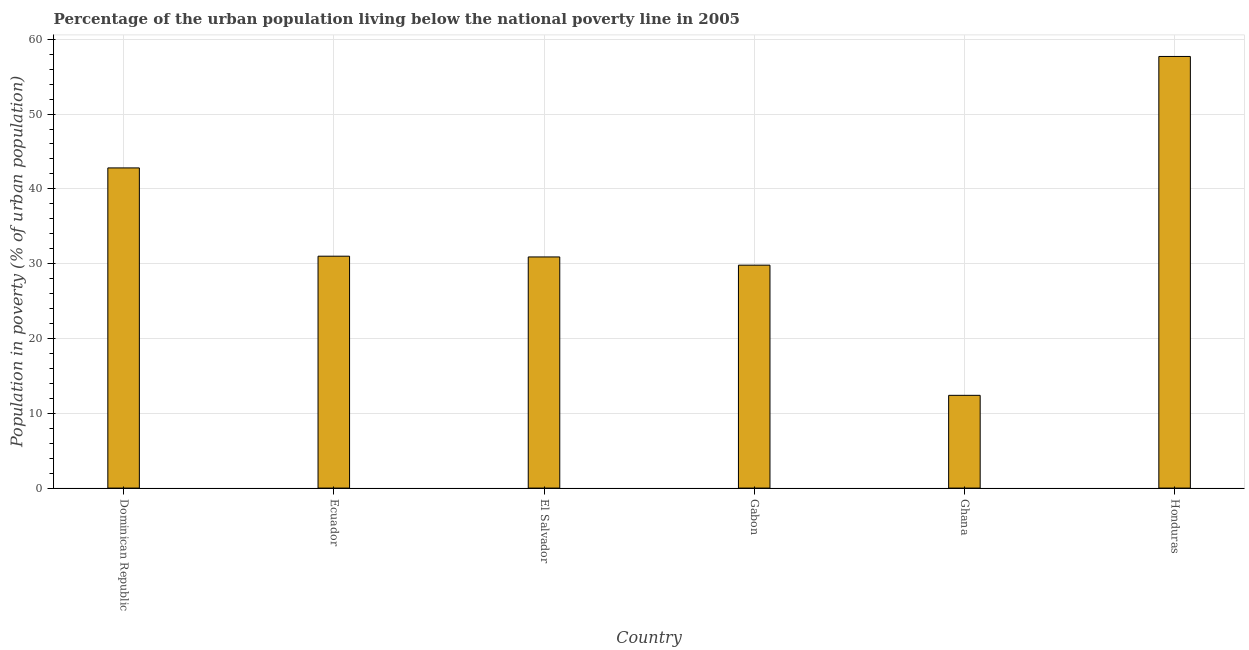What is the title of the graph?
Offer a terse response. Percentage of the urban population living below the national poverty line in 2005. What is the label or title of the X-axis?
Ensure brevity in your answer.  Country. What is the label or title of the Y-axis?
Ensure brevity in your answer.  Population in poverty (% of urban population). What is the percentage of urban population living below poverty line in Honduras?
Offer a terse response. 57.7. Across all countries, what is the maximum percentage of urban population living below poverty line?
Give a very brief answer. 57.7. Across all countries, what is the minimum percentage of urban population living below poverty line?
Keep it short and to the point. 12.4. In which country was the percentage of urban population living below poverty line maximum?
Provide a succinct answer. Honduras. In which country was the percentage of urban population living below poverty line minimum?
Make the answer very short. Ghana. What is the sum of the percentage of urban population living below poverty line?
Make the answer very short. 204.6. What is the difference between the percentage of urban population living below poverty line in Dominican Republic and Honduras?
Your answer should be very brief. -14.9. What is the average percentage of urban population living below poverty line per country?
Offer a very short reply. 34.1. What is the median percentage of urban population living below poverty line?
Offer a terse response. 30.95. What is the ratio of the percentage of urban population living below poverty line in Dominican Republic to that in Gabon?
Keep it short and to the point. 1.44. Is the difference between the percentage of urban population living below poverty line in Dominican Republic and El Salvador greater than the difference between any two countries?
Your response must be concise. No. What is the difference between the highest and the second highest percentage of urban population living below poverty line?
Give a very brief answer. 14.9. Is the sum of the percentage of urban population living below poverty line in El Salvador and Ghana greater than the maximum percentage of urban population living below poverty line across all countries?
Provide a short and direct response. No. What is the difference between the highest and the lowest percentage of urban population living below poverty line?
Offer a terse response. 45.3. In how many countries, is the percentage of urban population living below poverty line greater than the average percentage of urban population living below poverty line taken over all countries?
Ensure brevity in your answer.  2. How many bars are there?
Make the answer very short. 6. Are all the bars in the graph horizontal?
Give a very brief answer. No. How many countries are there in the graph?
Make the answer very short. 6. Are the values on the major ticks of Y-axis written in scientific E-notation?
Your answer should be compact. No. What is the Population in poverty (% of urban population) of Dominican Republic?
Provide a short and direct response. 42.8. What is the Population in poverty (% of urban population) of Ecuador?
Offer a terse response. 31. What is the Population in poverty (% of urban population) in El Salvador?
Make the answer very short. 30.9. What is the Population in poverty (% of urban population) in Gabon?
Offer a terse response. 29.8. What is the Population in poverty (% of urban population) in Ghana?
Provide a succinct answer. 12.4. What is the Population in poverty (% of urban population) of Honduras?
Your response must be concise. 57.7. What is the difference between the Population in poverty (% of urban population) in Dominican Republic and Ecuador?
Your answer should be very brief. 11.8. What is the difference between the Population in poverty (% of urban population) in Dominican Republic and Gabon?
Provide a short and direct response. 13. What is the difference between the Population in poverty (% of urban population) in Dominican Republic and Ghana?
Provide a succinct answer. 30.4. What is the difference between the Population in poverty (% of urban population) in Dominican Republic and Honduras?
Your response must be concise. -14.9. What is the difference between the Population in poverty (% of urban population) in Ecuador and Honduras?
Provide a short and direct response. -26.7. What is the difference between the Population in poverty (% of urban population) in El Salvador and Gabon?
Offer a very short reply. 1.1. What is the difference between the Population in poverty (% of urban population) in El Salvador and Ghana?
Provide a succinct answer. 18.5. What is the difference between the Population in poverty (% of urban population) in El Salvador and Honduras?
Make the answer very short. -26.8. What is the difference between the Population in poverty (% of urban population) in Gabon and Ghana?
Ensure brevity in your answer.  17.4. What is the difference between the Population in poverty (% of urban population) in Gabon and Honduras?
Your answer should be compact. -27.9. What is the difference between the Population in poverty (% of urban population) in Ghana and Honduras?
Your answer should be very brief. -45.3. What is the ratio of the Population in poverty (% of urban population) in Dominican Republic to that in Ecuador?
Your answer should be compact. 1.38. What is the ratio of the Population in poverty (% of urban population) in Dominican Republic to that in El Salvador?
Your answer should be compact. 1.39. What is the ratio of the Population in poverty (% of urban population) in Dominican Republic to that in Gabon?
Make the answer very short. 1.44. What is the ratio of the Population in poverty (% of urban population) in Dominican Republic to that in Ghana?
Your answer should be compact. 3.45. What is the ratio of the Population in poverty (% of urban population) in Dominican Republic to that in Honduras?
Make the answer very short. 0.74. What is the ratio of the Population in poverty (% of urban population) in Ecuador to that in Gabon?
Provide a succinct answer. 1.04. What is the ratio of the Population in poverty (% of urban population) in Ecuador to that in Honduras?
Give a very brief answer. 0.54. What is the ratio of the Population in poverty (% of urban population) in El Salvador to that in Ghana?
Give a very brief answer. 2.49. What is the ratio of the Population in poverty (% of urban population) in El Salvador to that in Honduras?
Provide a succinct answer. 0.54. What is the ratio of the Population in poverty (% of urban population) in Gabon to that in Ghana?
Ensure brevity in your answer.  2.4. What is the ratio of the Population in poverty (% of urban population) in Gabon to that in Honduras?
Keep it short and to the point. 0.52. What is the ratio of the Population in poverty (% of urban population) in Ghana to that in Honduras?
Offer a terse response. 0.21. 